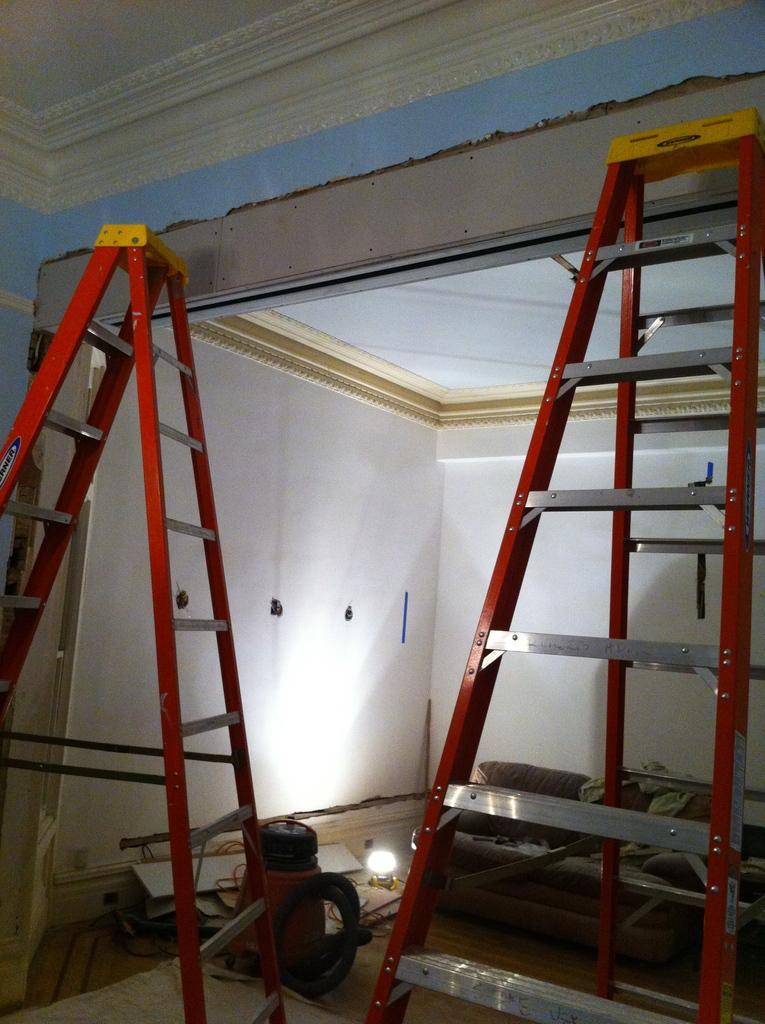What type of space is depicted in the image? The image shows the inner view of a room. What parts of the room can be seen in the image? The walls, roof, and ground are visible in the image. What special features are present in the room? There are objects like lasers and light in the room. What type of metal is used to make the chicken in the image? There is no chicken present in the image, so it is not possible to determine the type of metal used to make it. 